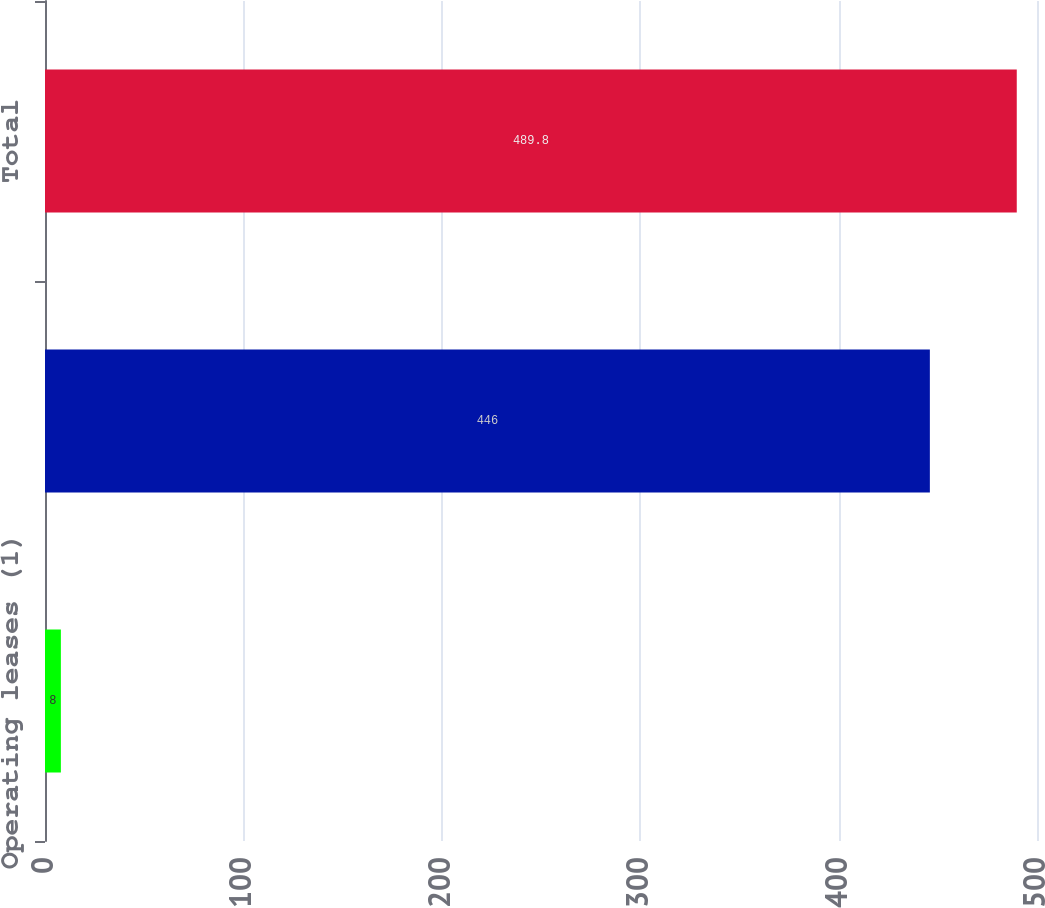<chart> <loc_0><loc_0><loc_500><loc_500><bar_chart><fcel>Operating leases (1)<fcel>Subtotal<fcel>Total<nl><fcel>8<fcel>446<fcel>489.8<nl></chart> 